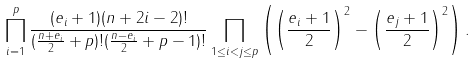<formula> <loc_0><loc_0><loc_500><loc_500>\prod _ { i = 1 } ^ { p } \frac { ( e _ { i } + 1 ) ( n + 2 i - 2 ) ! } { ( \frac { n + e _ { i } } { 2 } + p ) ! ( \frac { n - e _ { i } } { 2 } + p - 1 ) ! } \prod _ { 1 \leq i < j \leq p } \left ( \left ( \frac { e _ { i } + 1 } { 2 } \right ) ^ { 2 } - \left ( \frac { e _ { j } + 1 } { 2 } \right ) ^ { 2 } \right ) .</formula> 